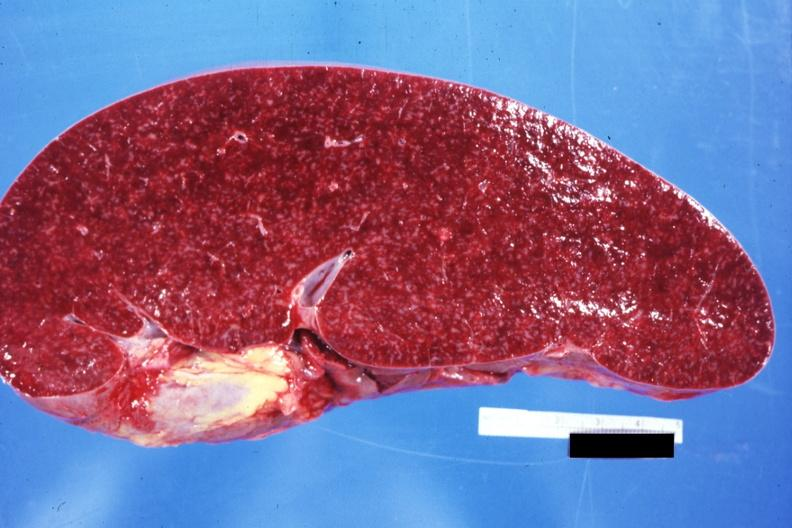what is present?
Answer the question using a single word or phrase. Lymphoma 